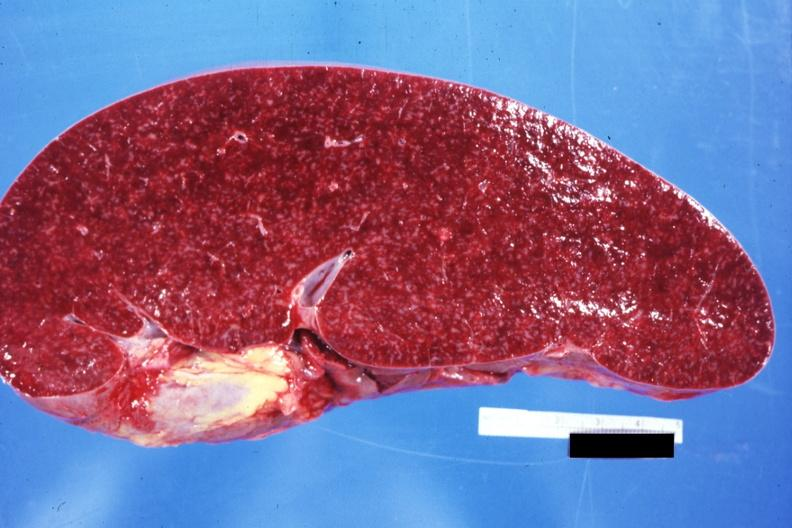what is present?
Answer the question using a single word or phrase. Lymphoma 